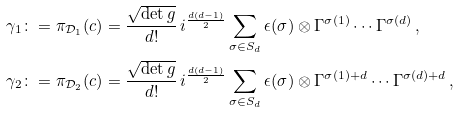<formula> <loc_0><loc_0><loc_500><loc_500>\gamma _ { 1 } & \colon = \pi _ { \mathcal { D } _ { 1 } } ( c ) = \frac { \sqrt { \det g } } { d ! } \, i ^ { \frac { d ( d - 1 ) } { 2 } } \sum _ { \sigma \in S _ { d } } \epsilon ( \sigma ) \otimes \Gamma ^ { \sigma ( 1 ) } \cdots \Gamma ^ { \sigma ( d ) } \, , \\ \gamma _ { 2 } & \colon = \pi _ { \mathcal { D } _ { 2 } } ( c ) = \frac { \sqrt { \det g } } { d ! } \, i ^ { \frac { d ( d - 1 ) } { 2 } } \sum _ { \sigma \in S _ { d } } \epsilon ( \sigma ) \otimes \Gamma ^ { \sigma ( 1 ) + d } \cdots \Gamma ^ { \sigma ( d ) + d } \, ,</formula> 